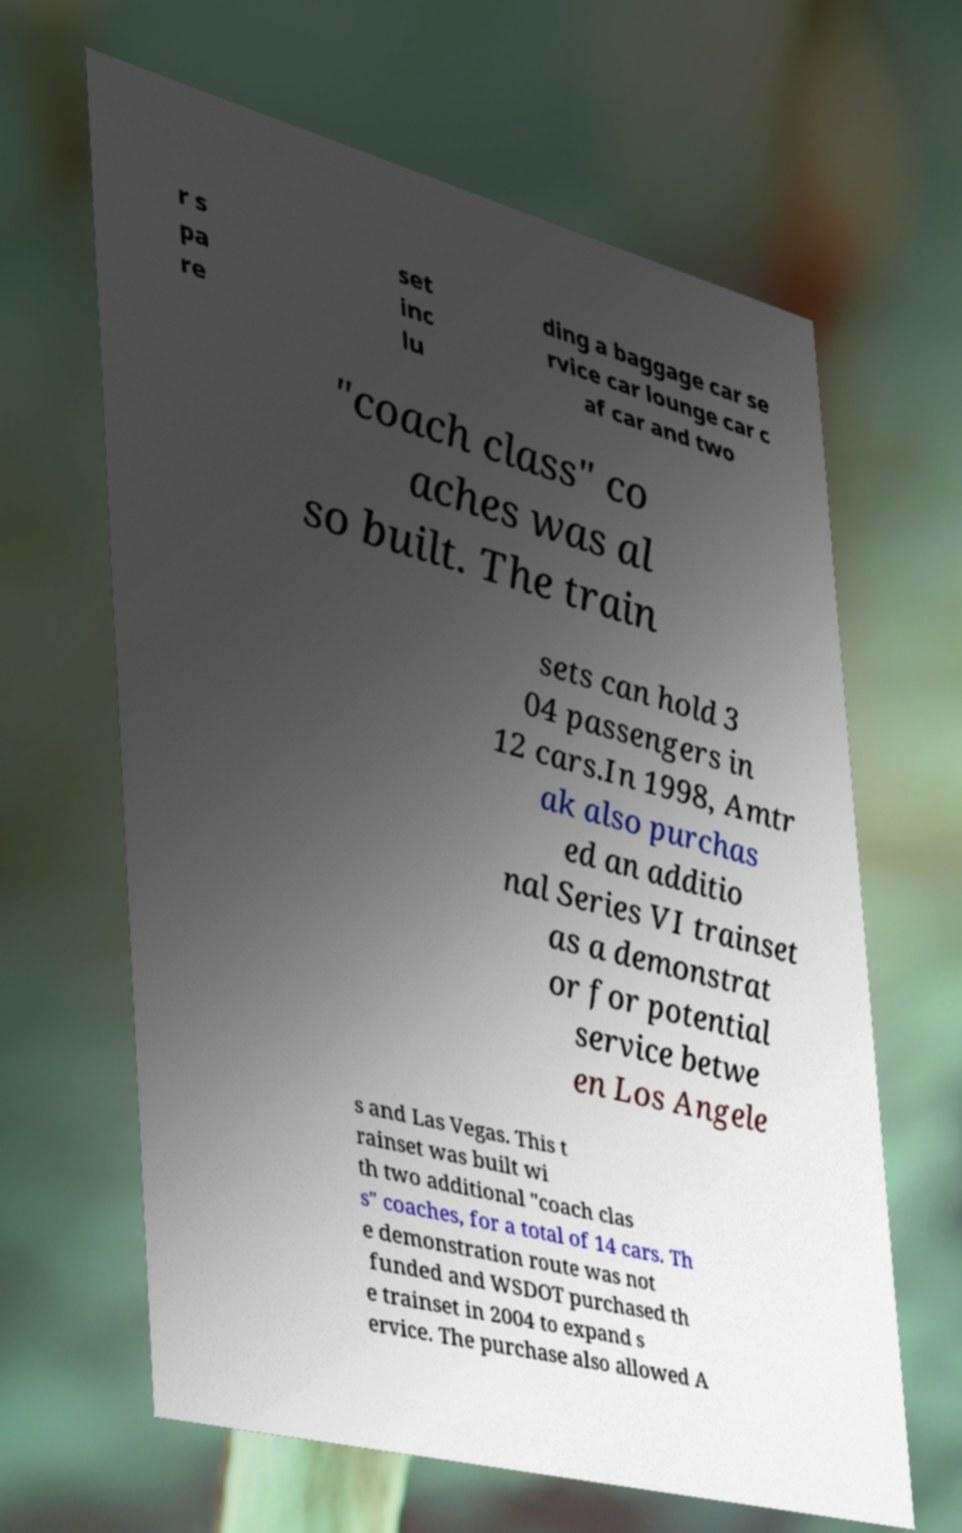What messages or text are displayed in this image? I need them in a readable, typed format. r s pa re set inc lu ding a baggage car se rvice car lounge car c af car and two "coach class" co aches was al so built. The train sets can hold 3 04 passengers in 12 cars.In 1998, Amtr ak also purchas ed an additio nal Series VI trainset as a demonstrat or for potential service betwe en Los Angele s and Las Vegas. This t rainset was built wi th two additional "coach clas s" coaches, for a total of 14 cars. Th e demonstration route was not funded and WSDOT purchased th e trainset in 2004 to expand s ervice. The purchase also allowed A 